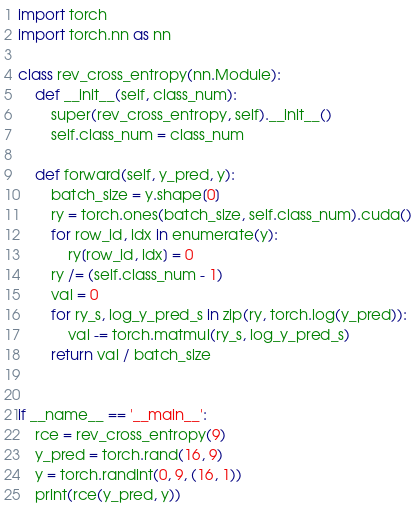<code> <loc_0><loc_0><loc_500><loc_500><_Python_>import torch
import torch.nn as nn

class rev_cross_entropy(nn.Module):
    def __init__(self, class_num):
        super(rev_cross_entropy, self).__init__()
        self.class_num = class_num
    
    def forward(self, y_pred, y):
        batch_size = y.shape[0]
        ry = torch.ones(batch_size, self.class_num).cuda()
        for row_id, idx in enumerate(y):
            ry[row_id, idx] = 0
        ry /= (self.class_num - 1)
        val = 0
        for ry_s, log_y_pred_s in zip(ry, torch.log(y_pred)):
            val -= torch.matmul(ry_s, log_y_pred_s)
        return val / batch_size


if __name__ == '__main__':
    rce = rev_cross_entropy(9)
    y_pred = torch.rand(16, 9)
    y = torch.randint(0, 9, (16, 1))
    print(rce(y_pred, y))


</code> 